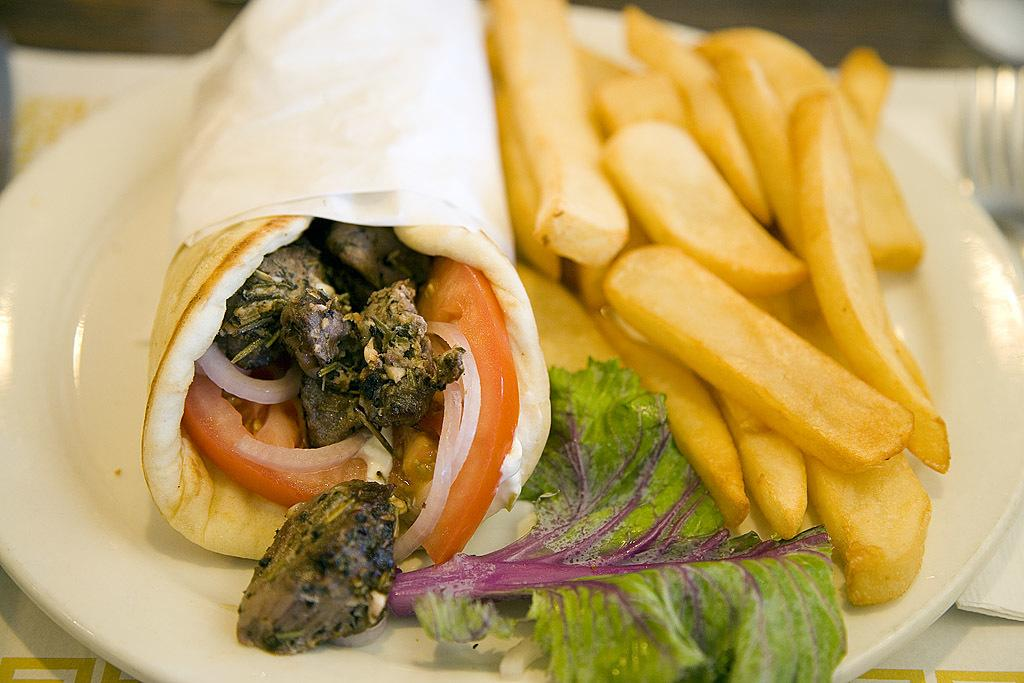What type of food is on the plate in the image? There are french fries on a plate in the image. What else is on the plate besides the french fries? There is a leaf and a roll on the plate. What is inside the roll? Inside the roll, there are onion, tomato, tomato, and meat. What utensil is on the table in the image? There is a fork on the table. What can be used for wiping or drying in the image? There are tissues on the table. Can you tell me how many cacti are on the plate in the image? There are no cacti present on the plate or in the image. What type of shoe is visible in the image? There is no shoe visible in the image. 